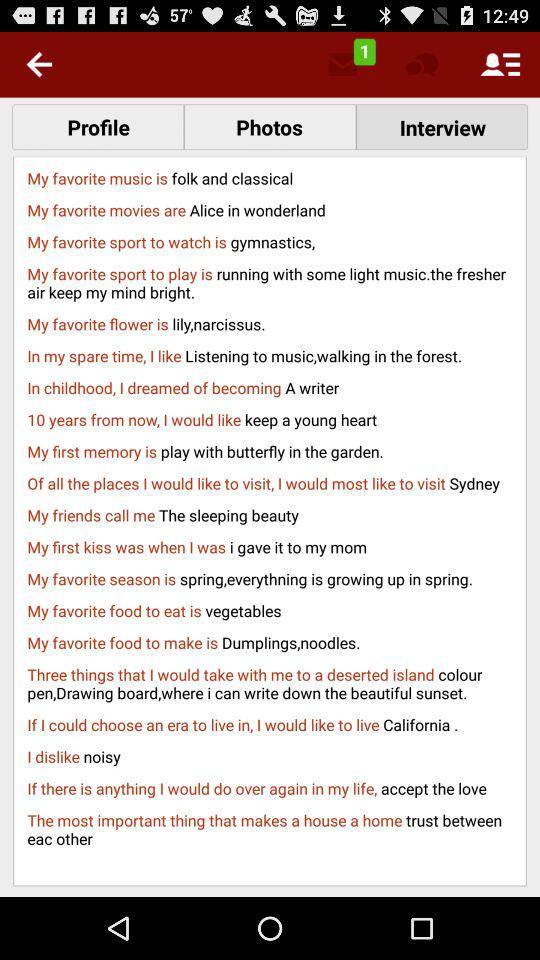How many unread messages are there? There is 1 unread message. 